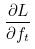<formula> <loc_0><loc_0><loc_500><loc_500>\frac { \partial L } { \partial f _ { t } }</formula> 